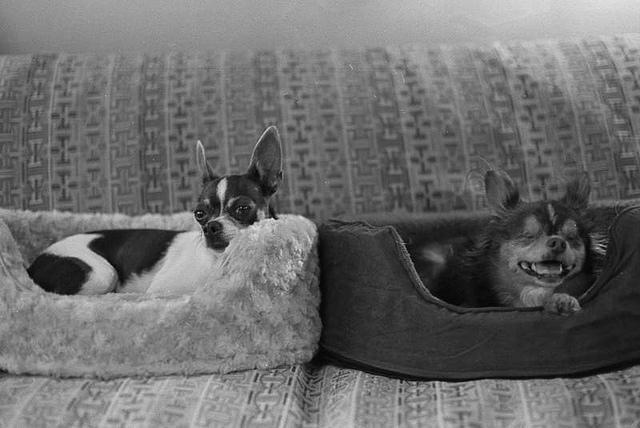How many dogs are in their beds?
Give a very brief answer. 2. How many dogs can you see?
Give a very brief answer. 2. How many people in the front row are smiling?
Give a very brief answer. 0. 